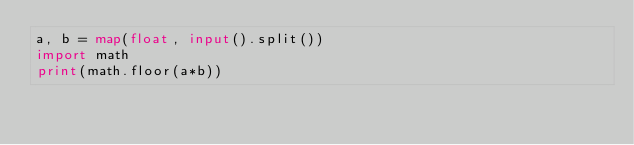Convert code to text. <code><loc_0><loc_0><loc_500><loc_500><_Python_>a, b = map(float, input().split())
import math
print(math.floor(a*b))</code> 